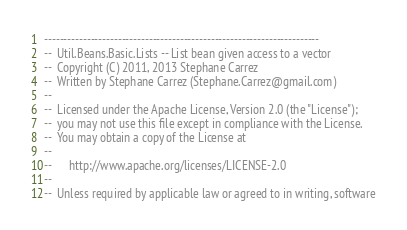<code> <loc_0><loc_0><loc_500><loc_500><_Ada_>-----------------------------------------------------------------------
--  Util.Beans.Basic.Lists -- List bean given access to a vector
--  Copyright (C) 2011, 2013 Stephane Carrez
--  Written by Stephane Carrez (Stephane.Carrez@gmail.com)
--
--  Licensed under the Apache License, Version 2.0 (the "License");
--  you may not use this file except in compliance with the License.
--  You may obtain a copy of the License at
--
--      http://www.apache.org/licenses/LICENSE-2.0
--
--  Unless required by applicable law or agreed to in writing, software</code> 